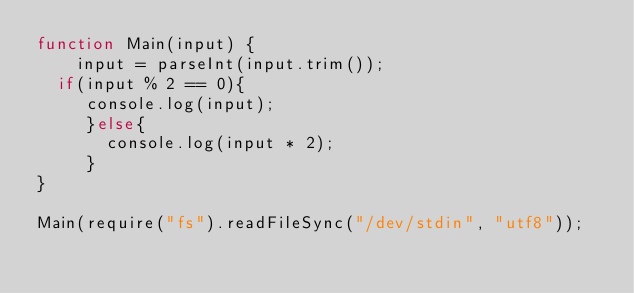Convert code to text. <code><loc_0><loc_0><loc_500><loc_500><_JavaScript_>function Main(input) {
	input = parseInt(input.trim());
  if(input % 2 == 0){
     console.log(input);
     }else{
       console.log(input * 2);
     }
}

Main(require("fs").readFileSync("/dev/stdin", "utf8"));
</code> 